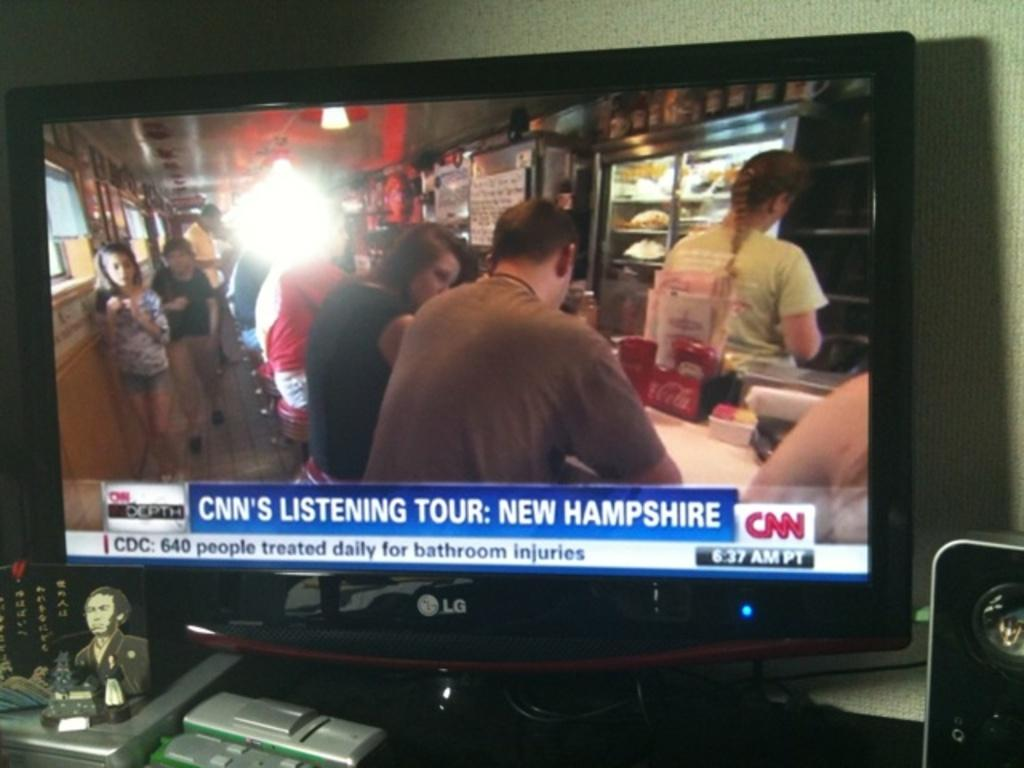<image>
Summarize the visual content of the image. A tv screen showing a CNN's listening tour broadcast. 